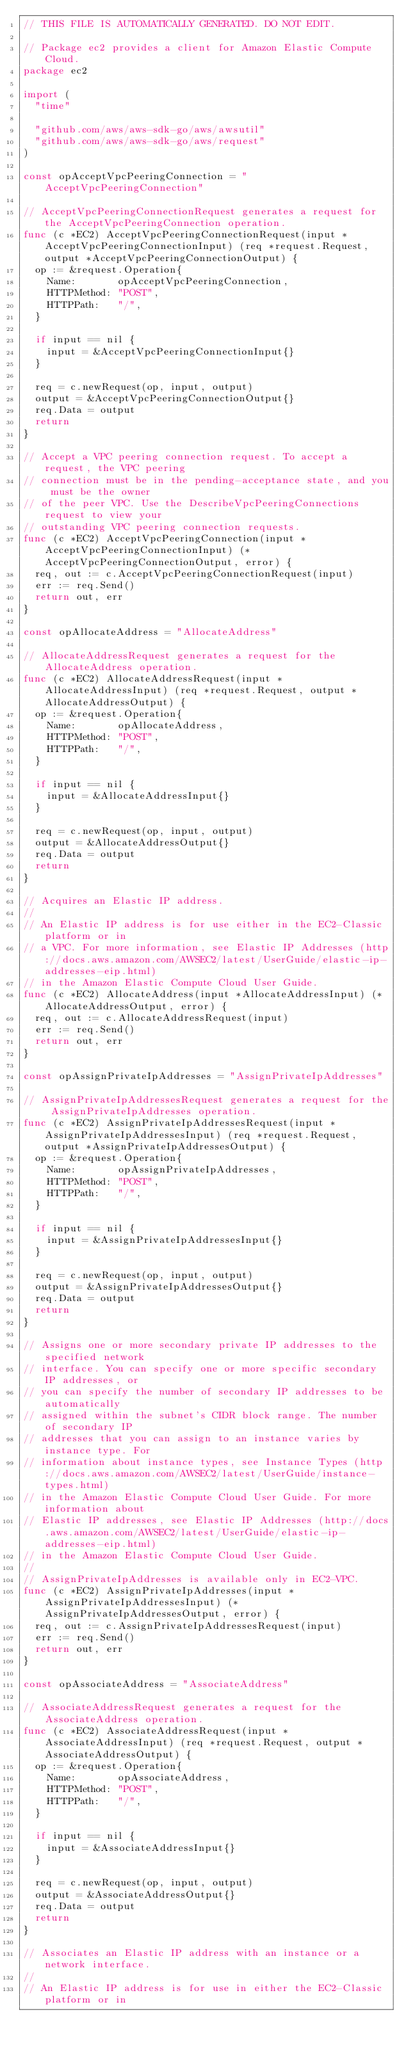Convert code to text. <code><loc_0><loc_0><loc_500><loc_500><_Go_>// THIS FILE IS AUTOMATICALLY GENERATED. DO NOT EDIT.

// Package ec2 provides a client for Amazon Elastic Compute Cloud.
package ec2

import (
	"time"

	"github.com/aws/aws-sdk-go/aws/awsutil"
	"github.com/aws/aws-sdk-go/aws/request"
)

const opAcceptVpcPeeringConnection = "AcceptVpcPeeringConnection"

// AcceptVpcPeeringConnectionRequest generates a request for the AcceptVpcPeeringConnection operation.
func (c *EC2) AcceptVpcPeeringConnectionRequest(input *AcceptVpcPeeringConnectionInput) (req *request.Request, output *AcceptVpcPeeringConnectionOutput) {
	op := &request.Operation{
		Name:       opAcceptVpcPeeringConnection,
		HTTPMethod: "POST",
		HTTPPath:   "/",
	}

	if input == nil {
		input = &AcceptVpcPeeringConnectionInput{}
	}

	req = c.newRequest(op, input, output)
	output = &AcceptVpcPeeringConnectionOutput{}
	req.Data = output
	return
}

// Accept a VPC peering connection request. To accept a request, the VPC peering
// connection must be in the pending-acceptance state, and you must be the owner
// of the peer VPC. Use the DescribeVpcPeeringConnections request to view your
// outstanding VPC peering connection requests.
func (c *EC2) AcceptVpcPeeringConnection(input *AcceptVpcPeeringConnectionInput) (*AcceptVpcPeeringConnectionOutput, error) {
	req, out := c.AcceptVpcPeeringConnectionRequest(input)
	err := req.Send()
	return out, err
}

const opAllocateAddress = "AllocateAddress"

// AllocateAddressRequest generates a request for the AllocateAddress operation.
func (c *EC2) AllocateAddressRequest(input *AllocateAddressInput) (req *request.Request, output *AllocateAddressOutput) {
	op := &request.Operation{
		Name:       opAllocateAddress,
		HTTPMethod: "POST",
		HTTPPath:   "/",
	}

	if input == nil {
		input = &AllocateAddressInput{}
	}

	req = c.newRequest(op, input, output)
	output = &AllocateAddressOutput{}
	req.Data = output
	return
}

// Acquires an Elastic IP address.
//
// An Elastic IP address is for use either in the EC2-Classic platform or in
// a VPC. For more information, see Elastic IP Addresses (http://docs.aws.amazon.com/AWSEC2/latest/UserGuide/elastic-ip-addresses-eip.html)
// in the Amazon Elastic Compute Cloud User Guide.
func (c *EC2) AllocateAddress(input *AllocateAddressInput) (*AllocateAddressOutput, error) {
	req, out := c.AllocateAddressRequest(input)
	err := req.Send()
	return out, err
}

const opAssignPrivateIpAddresses = "AssignPrivateIpAddresses"

// AssignPrivateIpAddressesRequest generates a request for the AssignPrivateIpAddresses operation.
func (c *EC2) AssignPrivateIpAddressesRequest(input *AssignPrivateIpAddressesInput) (req *request.Request, output *AssignPrivateIpAddressesOutput) {
	op := &request.Operation{
		Name:       opAssignPrivateIpAddresses,
		HTTPMethod: "POST",
		HTTPPath:   "/",
	}

	if input == nil {
		input = &AssignPrivateIpAddressesInput{}
	}

	req = c.newRequest(op, input, output)
	output = &AssignPrivateIpAddressesOutput{}
	req.Data = output
	return
}

// Assigns one or more secondary private IP addresses to the specified network
// interface. You can specify one or more specific secondary IP addresses, or
// you can specify the number of secondary IP addresses to be automatically
// assigned within the subnet's CIDR block range. The number of secondary IP
// addresses that you can assign to an instance varies by instance type. For
// information about instance types, see Instance Types (http://docs.aws.amazon.com/AWSEC2/latest/UserGuide/instance-types.html)
// in the Amazon Elastic Compute Cloud User Guide. For more information about
// Elastic IP addresses, see Elastic IP Addresses (http://docs.aws.amazon.com/AWSEC2/latest/UserGuide/elastic-ip-addresses-eip.html)
// in the Amazon Elastic Compute Cloud User Guide.
//
// AssignPrivateIpAddresses is available only in EC2-VPC.
func (c *EC2) AssignPrivateIpAddresses(input *AssignPrivateIpAddressesInput) (*AssignPrivateIpAddressesOutput, error) {
	req, out := c.AssignPrivateIpAddressesRequest(input)
	err := req.Send()
	return out, err
}

const opAssociateAddress = "AssociateAddress"

// AssociateAddressRequest generates a request for the AssociateAddress operation.
func (c *EC2) AssociateAddressRequest(input *AssociateAddressInput) (req *request.Request, output *AssociateAddressOutput) {
	op := &request.Operation{
		Name:       opAssociateAddress,
		HTTPMethod: "POST",
		HTTPPath:   "/",
	}

	if input == nil {
		input = &AssociateAddressInput{}
	}

	req = c.newRequest(op, input, output)
	output = &AssociateAddressOutput{}
	req.Data = output
	return
}

// Associates an Elastic IP address with an instance or a network interface.
//
// An Elastic IP address is for use in either the EC2-Classic platform or in</code> 